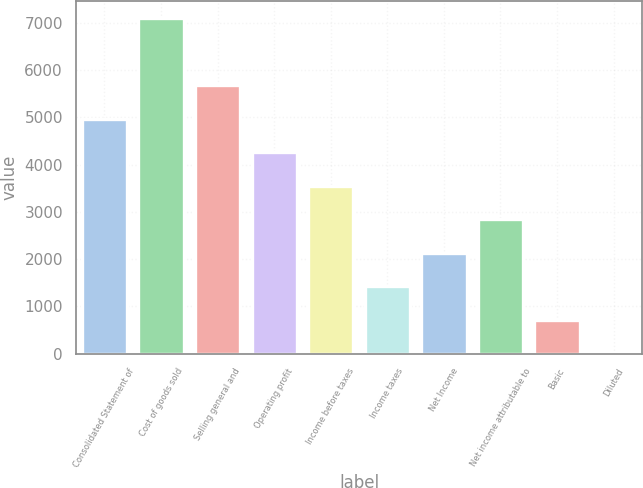Convert chart. <chart><loc_0><loc_0><loc_500><loc_500><bar_chart><fcel>Consolidated Statement of<fcel>Cost of goods sold<fcel>Selling general and<fcel>Operating profit<fcel>Income before taxes<fcel>Income taxes<fcel>Net Income<fcel>Net income attributable to<fcel>Basic<fcel>Diluted<nl><fcel>4976.59<fcel>7108<fcel>5687.06<fcel>4266.12<fcel>3555.65<fcel>1424.24<fcel>2134.71<fcel>2845.18<fcel>713.77<fcel>3.3<nl></chart> 